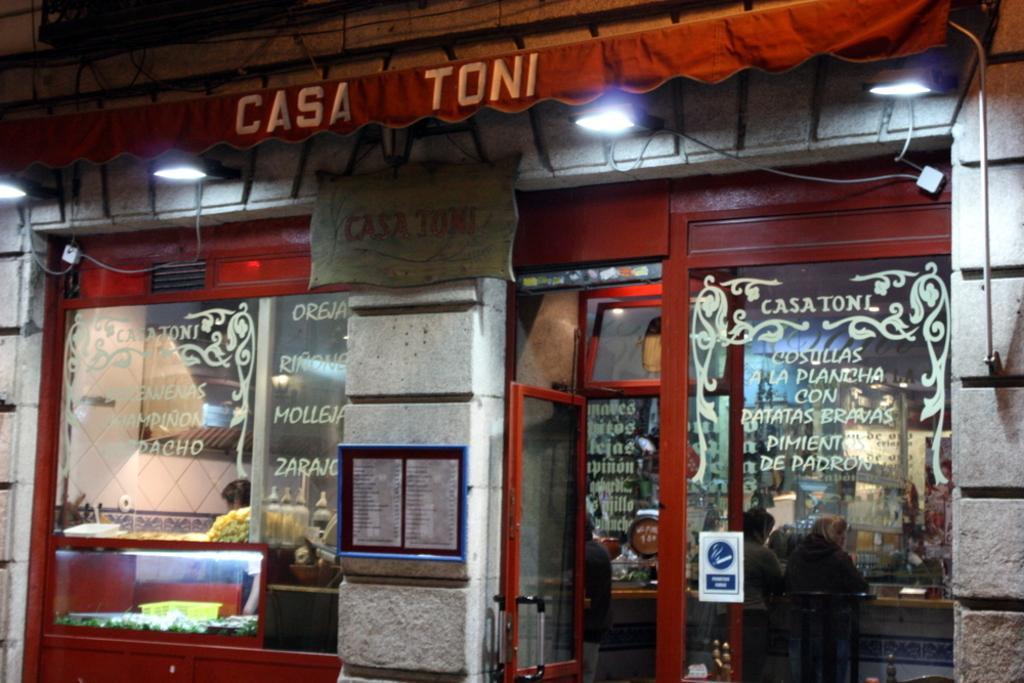In one or two sentences, can you explain what this image depicts? In this image we can see the shop, we can see the glass doors and some written text on it, near that we can see the menu board, after that we can see lights, beside that we can see curtains and some text written on it, we can see the concrete wall. And few people are sitting on the chairs. 